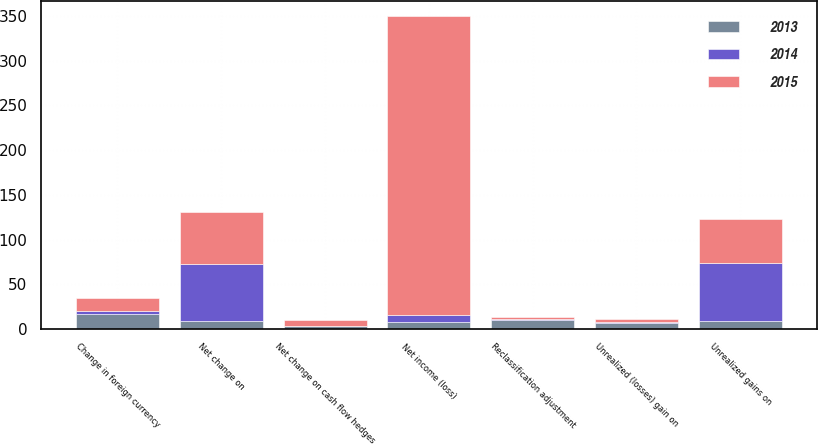<chart> <loc_0><loc_0><loc_500><loc_500><stacked_bar_chart><ecel><fcel>Net income (loss)<fcel>Unrealized gains on<fcel>Reclassification adjustment<fcel>Net change on<fcel>Unrealized (losses) gain on<fcel>Net change on cash flow hedges<fcel>Change in foreign currency<nl><fcel>2013<fcel>7.65<fcel>9.1<fcel>9.6<fcel>8.6<fcel>6.7<fcel>2.9<fcel>16.9<nl><fcel>2015<fcel>334.3<fcel>48.7<fcel>2.3<fcel>57.8<fcel>4.1<fcel>6.4<fcel>14.2<nl><fcel>2014<fcel>7.65<fcel>65.1<fcel>1.5<fcel>64.1<fcel>0.7<fcel>0.8<fcel>3.4<nl></chart> 